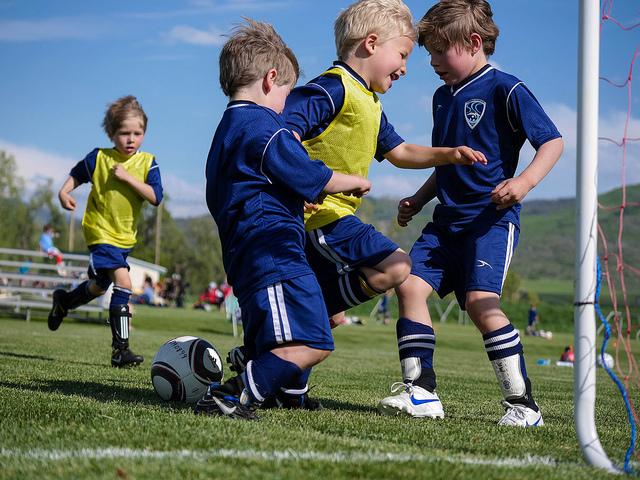How many pairs of Nikes are visible?
Keep it brief. 3. Are the guys in blue wearing two different socks?
Be succinct. No. What type of ball can be seen?
Be succinct. Soccer. What is this sport?
Give a very brief answer. Soccer. What color are the uniforms?
Quick response, please. Blue. How many boys are playing?
Answer briefly. 4. What game is being played?
Quick response, please. Soccer. 